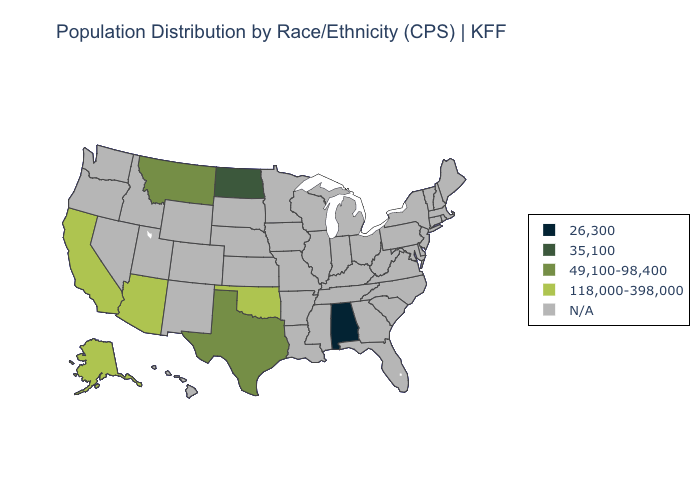What is the value of New Mexico?
Answer briefly. N/A. Which states hav the highest value in the West?
Write a very short answer. Alaska, Arizona, California. Name the states that have a value in the range 49,100-98,400?
Be succinct. Montana, Texas. Does Alabama have the lowest value in the USA?
Short answer required. Yes. Name the states that have a value in the range 49,100-98,400?
Write a very short answer. Montana, Texas. Is the legend a continuous bar?
Short answer required. No. What is the lowest value in the MidWest?
Concise answer only. 35,100. Is the legend a continuous bar?
Write a very short answer. No. Name the states that have a value in the range 118,000-398,000?
Answer briefly. Alaska, Arizona, California, Oklahoma. Which states have the lowest value in the USA?
Quick response, please. Alabama. Name the states that have a value in the range 118,000-398,000?
Give a very brief answer. Alaska, Arizona, California, Oklahoma. 